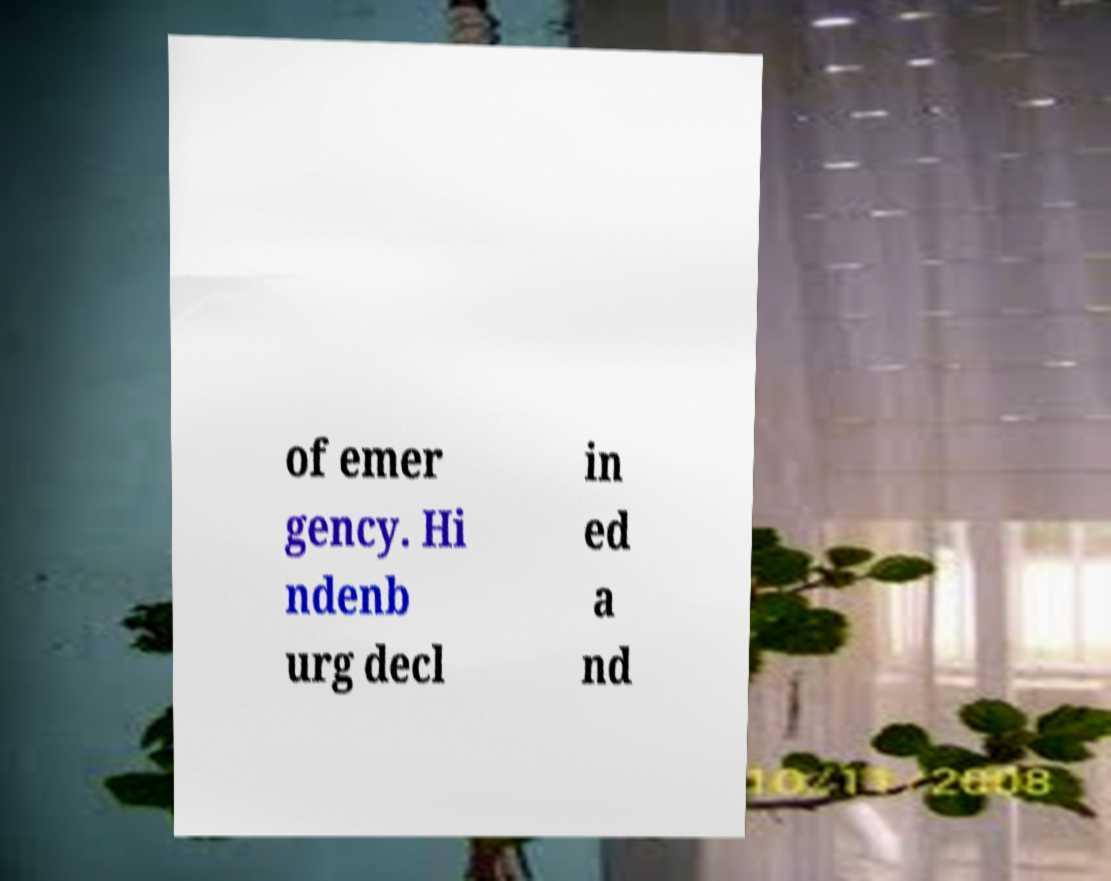Can you accurately transcribe the text from the provided image for me? of emer gency. Hi ndenb urg decl in ed a nd 